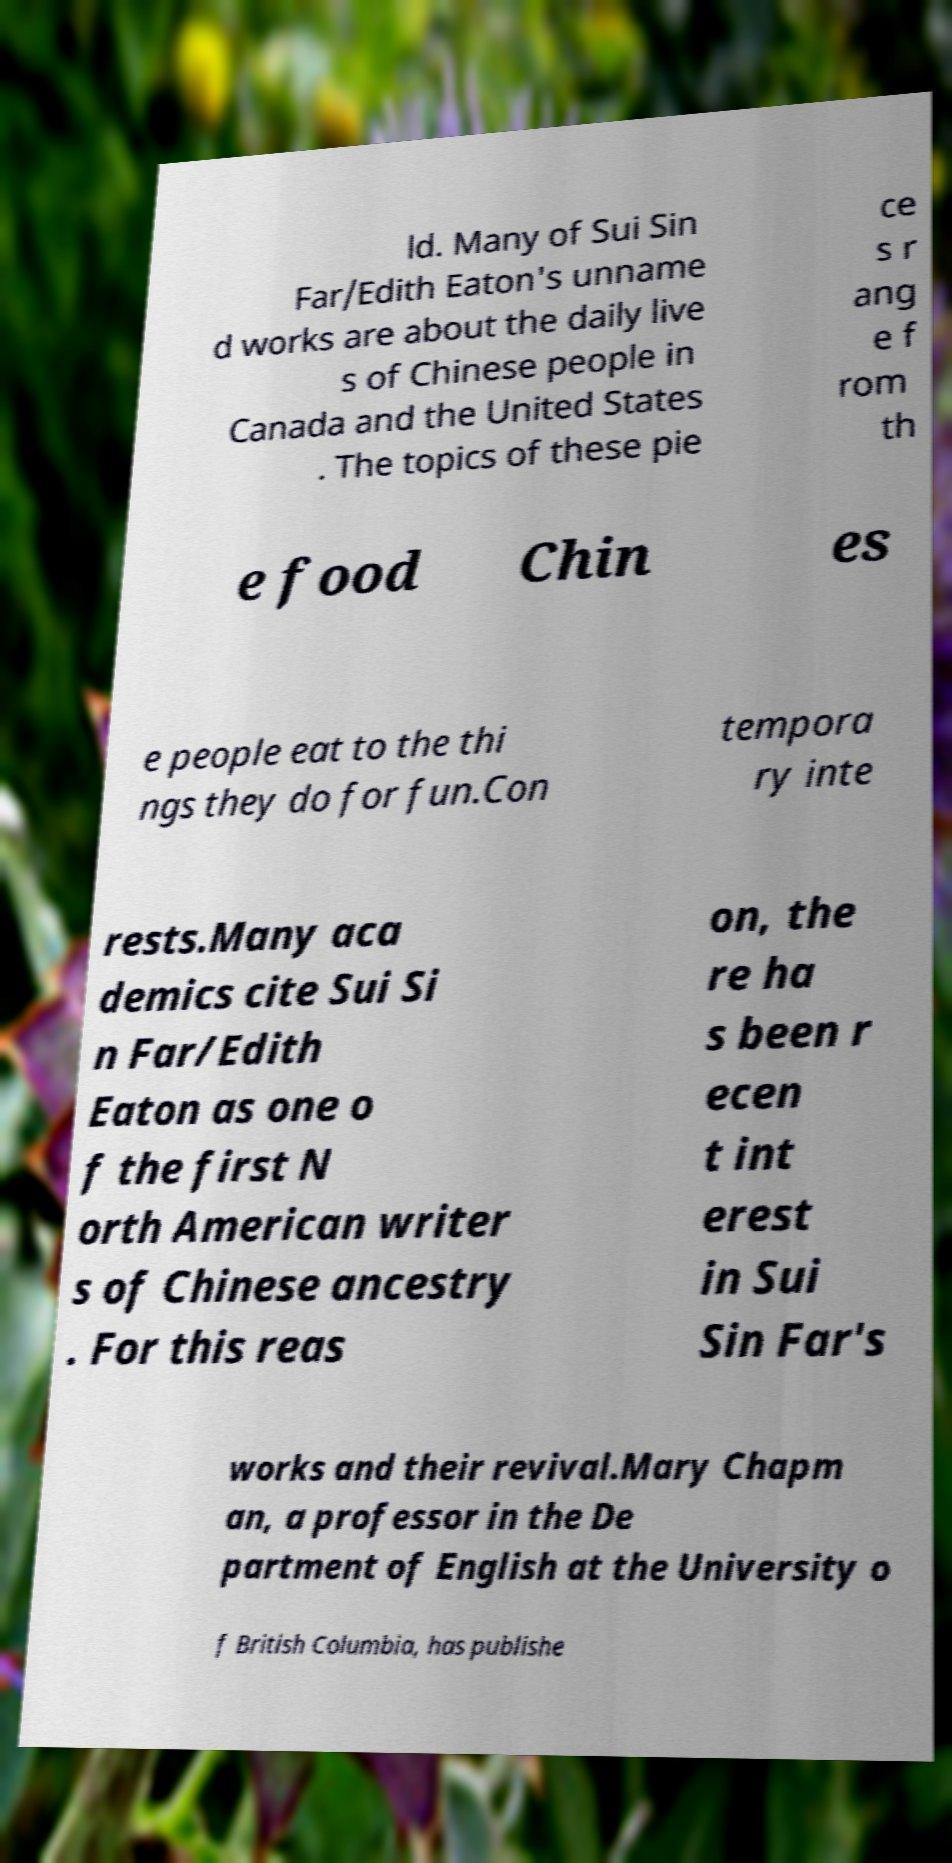Please identify and transcribe the text found in this image. ld. Many of Sui Sin Far/Edith Eaton's unname d works are about the daily live s of Chinese people in Canada and the United States . The topics of these pie ce s r ang e f rom th e food Chin es e people eat to the thi ngs they do for fun.Con tempora ry inte rests.Many aca demics cite Sui Si n Far/Edith Eaton as one o f the first N orth American writer s of Chinese ancestry . For this reas on, the re ha s been r ecen t int erest in Sui Sin Far's works and their revival.Mary Chapm an, a professor in the De partment of English at the University o f British Columbia, has publishe 